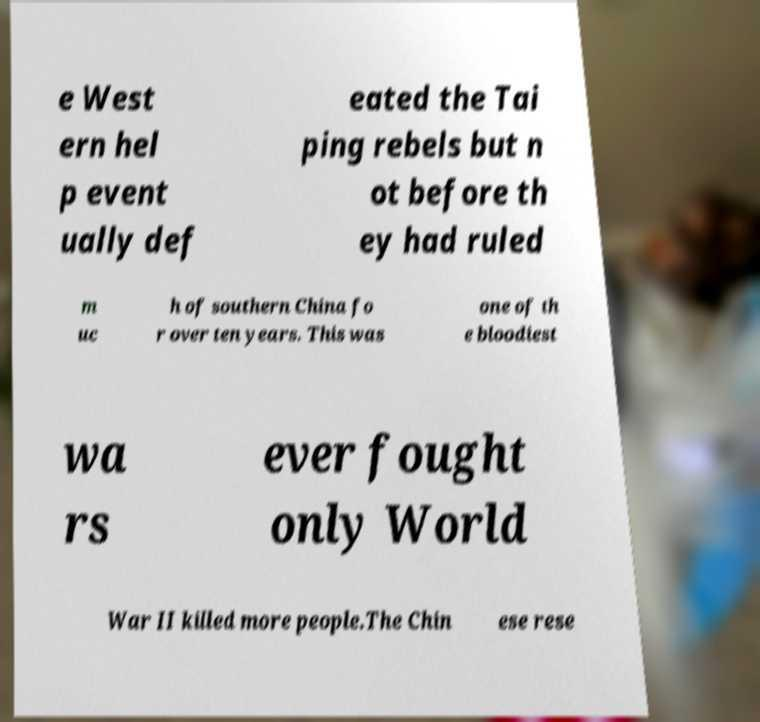Please identify and transcribe the text found in this image. e West ern hel p event ually def eated the Tai ping rebels but n ot before th ey had ruled m uc h of southern China fo r over ten years. This was one of th e bloodiest wa rs ever fought only World War II killed more people.The Chin ese rese 